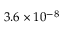<formula> <loc_0><loc_0><loc_500><loc_500>3 . 6 \times 1 0 ^ { - 8 }</formula> 